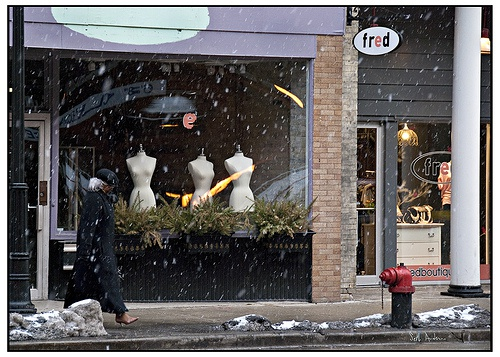Describe the objects in this image and their specific colors. I can see people in white, black, gray, and darkgray tones and fire hydrant in white, black, maroon, and brown tones in this image. 